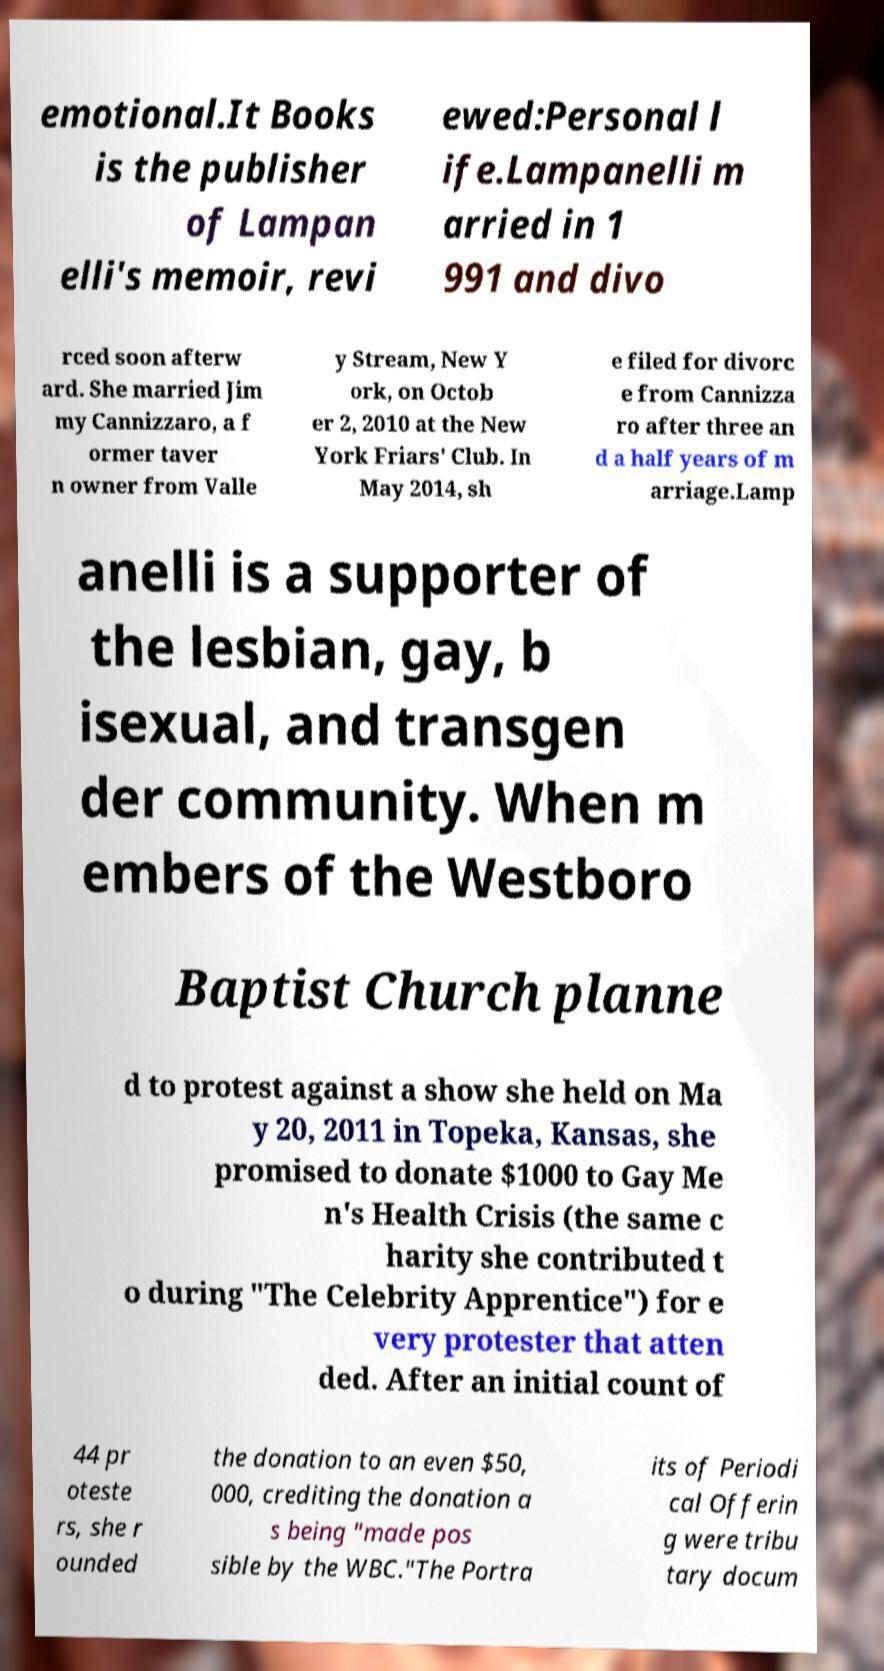What messages or text are displayed in this image? I need them in a readable, typed format. emotional.It Books is the publisher of Lampan elli's memoir, revi ewed:Personal l ife.Lampanelli m arried in 1 991 and divo rced soon afterw ard. She married Jim my Cannizzaro, a f ormer taver n owner from Valle y Stream, New Y ork, on Octob er 2, 2010 at the New York Friars' Club. In May 2014, sh e filed for divorc e from Cannizza ro after three an d a half years of m arriage.Lamp anelli is a supporter of the lesbian, gay, b isexual, and transgen der community. When m embers of the Westboro Baptist Church planne d to protest against a show she held on Ma y 20, 2011 in Topeka, Kansas, she promised to donate $1000 to Gay Me n's Health Crisis (the same c harity she contributed t o during "The Celebrity Apprentice") for e very protester that atten ded. After an initial count of 44 pr oteste rs, she r ounded the donation to an even $50, 000, crediting the donation a s being "made pos sible by the WBC."The Portra its of Periodi cal Offerin g were tribu tary docum 